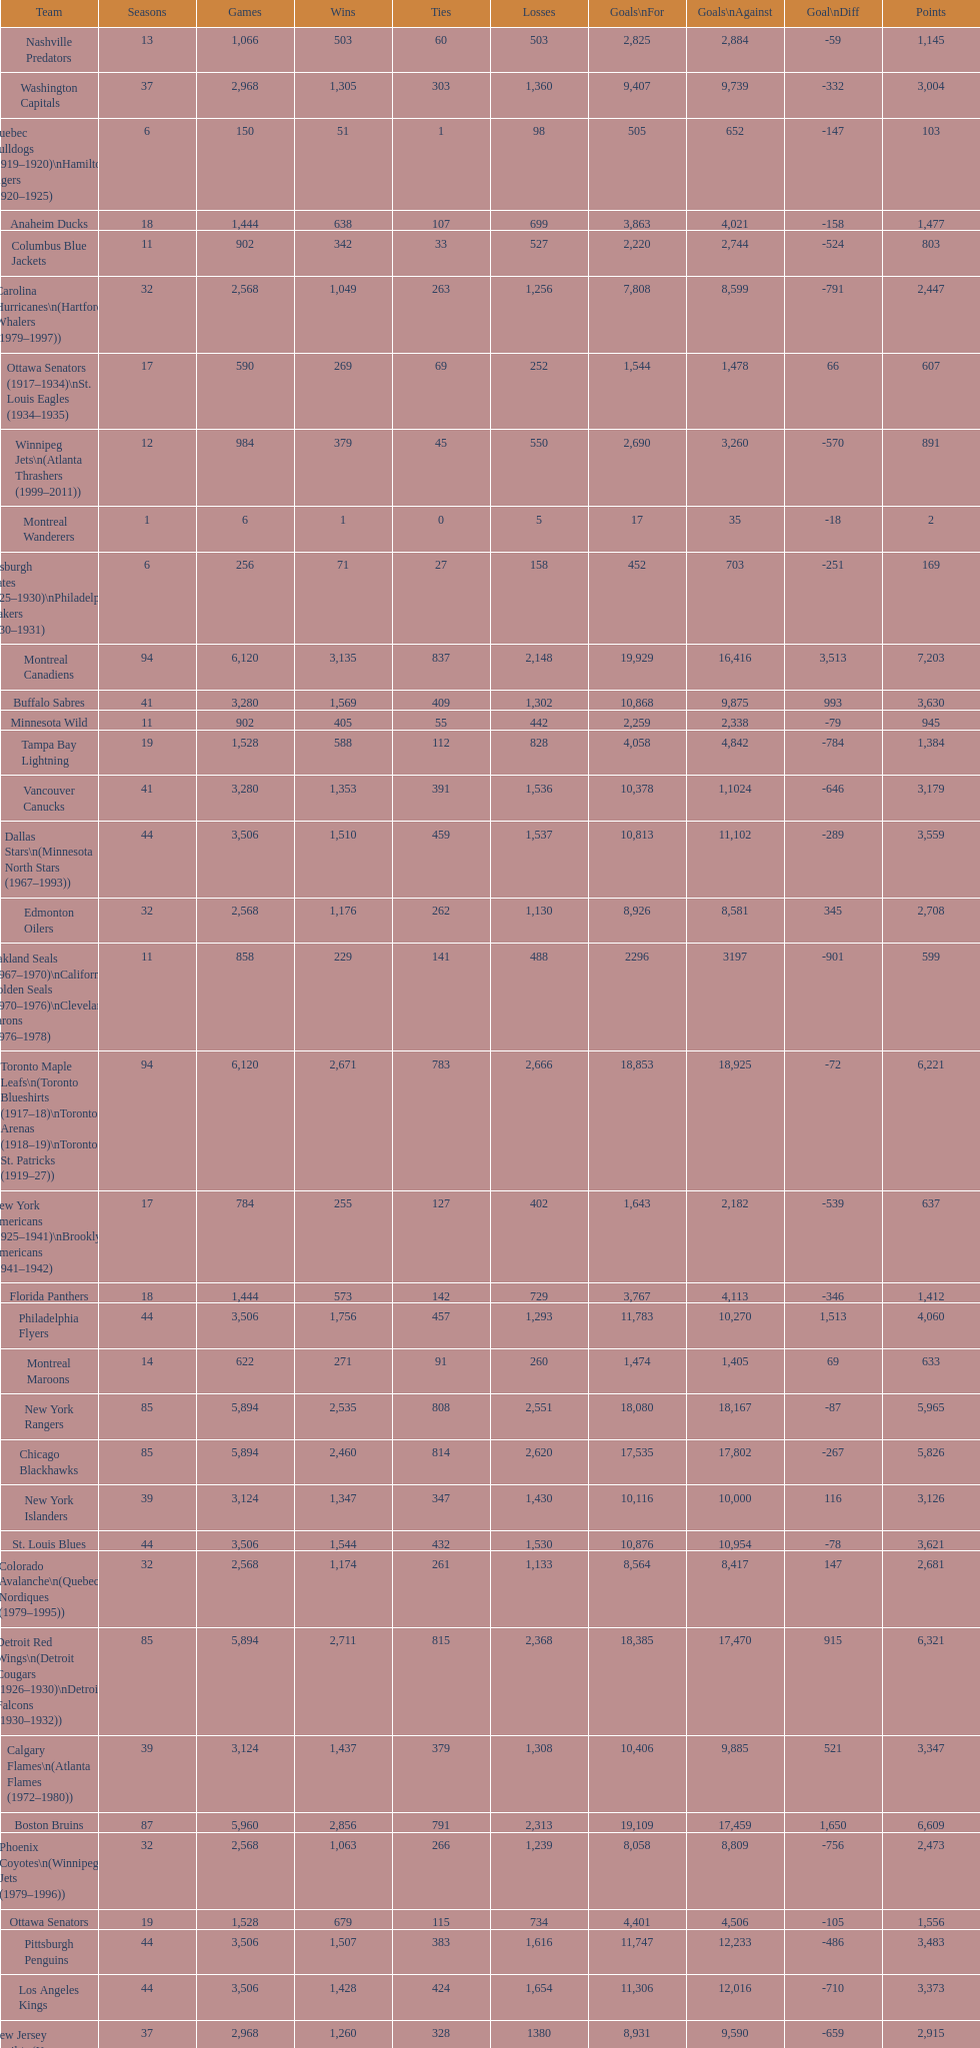Who is at the top of the list? Montreal Canadiens. 